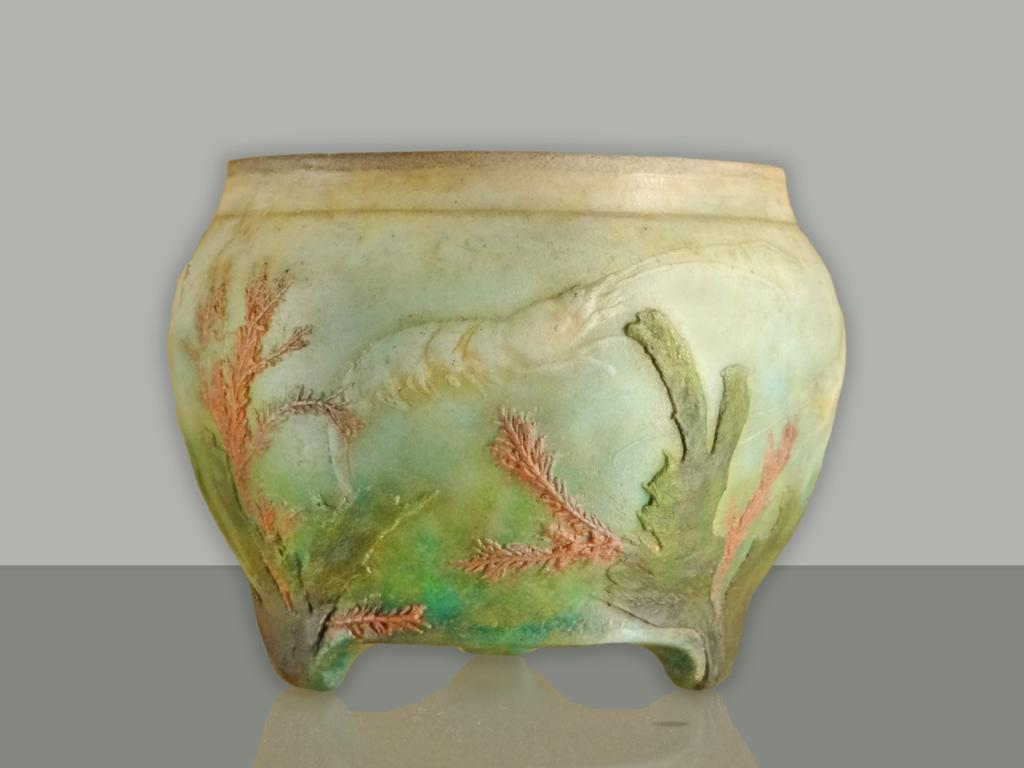What can be seen in the image? There is an object in the image. Can you describe the colors of the object? The object has green and pink colors. What flavor of potato is being served in the image? There is no potato or any food item present in the image, so it is not possible to determine the flavor of any potato. 